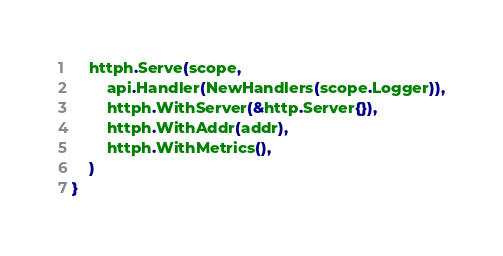<code> <loc_0><loc_0><loc_500><loc_500><_Go_>	httph.Serve(scope,
		api.Handler(NewHandlers(scope.Logger)),
		httph.WithServer(&http.Server{}),
		httph.WithAddr(addr),
		httph.WithMetrics(),
	)
}
</code> 